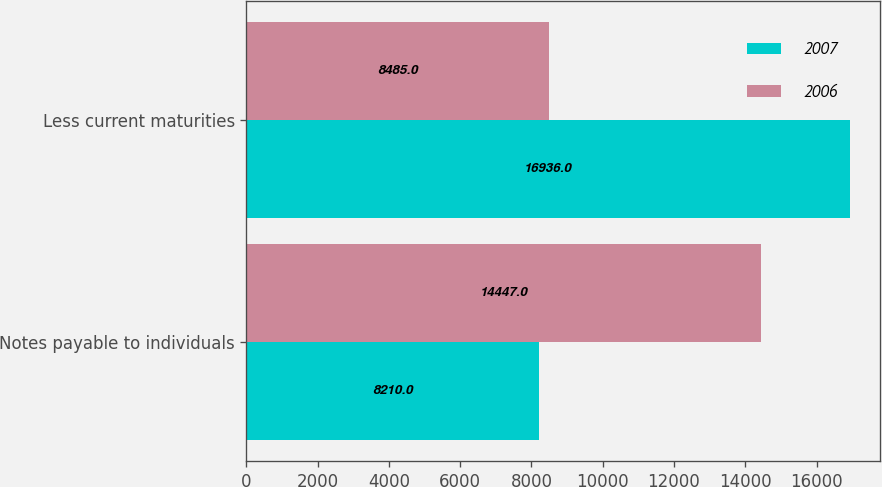Convert chart. <chart><loc_0><loc_0><loc_500><loc_500><stacked_bar_chart><ecel><fcel>Notes payable to individuals<fcel>Less current maturities<nl><fcel>2007<fcel>8210<fcel>16936<nl><fcel>2006<fcel>14447<fcel>8485<nl></chart> 